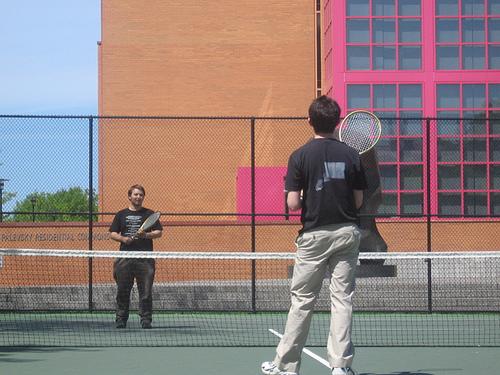Is this a professional game being played?
Answer briefly. No. What sport is this?
Keep it brief. Tennis. What sport is being played?
Short answer required. Tennis. What color is the window pane?
Quick response, please. Pink. 